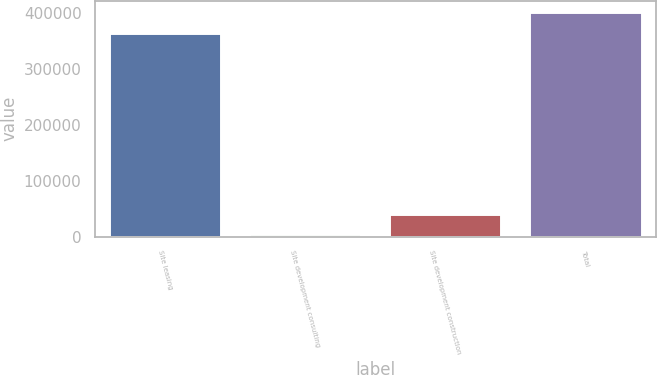<chart> <loc_0><loc_0><loc_500><loc_500><bar_chart><fcel>Site leasing<fcel>Site development consulting<fcel>Site development construction<fcel>Total<nl><fcel>365165<fcel>4174<fcel>41253.6<fcel>402245<nl></chart> 